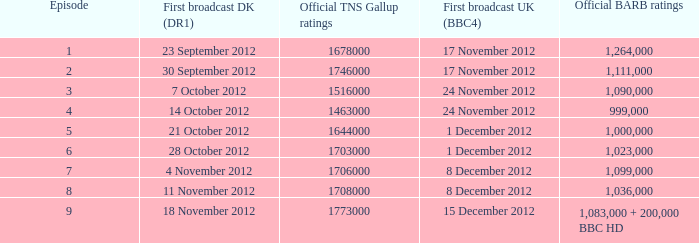When was the episode with a 1,036,000 BARB rating first aired in Denmark? 11 November 2012. 